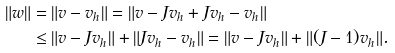Convert formula to latex. <formula><loc_0><loc_0><loc_500><loc_500>\| w \| & = \| v - v _ { h } \| = \| v - J v _ { h } + J v _ { h } - v _ { h } \| \\ & \leq \| v - J v _ { h } \| + \| J v _ { h } - v _ { h } \| = \| v - J v _ { h } \| + \| ( J - 1 ) v _ { h } \| .</formula> 